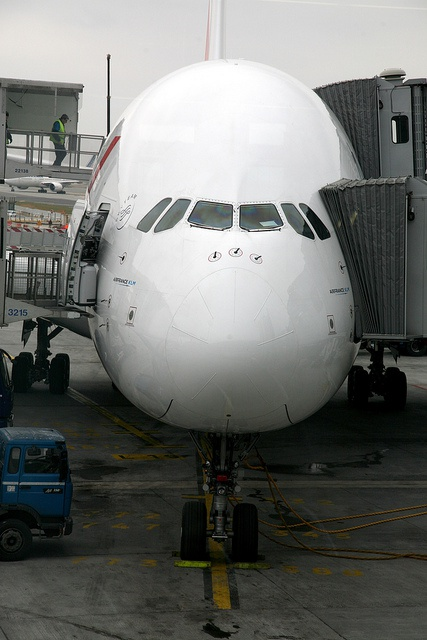Describe the objects in this image and their specific colors. I can see airplane in lightgray, gray, darkgray, and black tones, truck in lightgray, black, darkblue, gray, and purple tones, airplane in lightgray, gray, darkgray, and black tones, and people in lightgray, black, darkgreen, and darkblue tones in this image. 